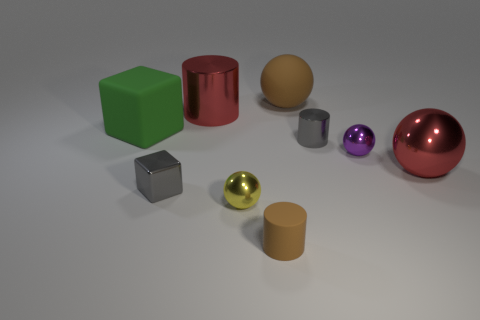There is a brown object that is in front of the small shiny cylinder; what is its shape?
Keep it short and to the point. Cylinder. What is the size of the other cylinder that is made of the same material as the big red cylinder?
Make the answer very short. Small. The matte object that is both in front of the large red cylinder and behind the tiny yellow metallic thing has what shape?
Offer a terse response. Cube. There is a large rubber object that is to the left of the big matte sphere; does it have the same color as the big cylinder?
Make the answer very short. No. There is a small purple shiny thing behind the brown matte cylinder; does it have the same shape as the big shiny object to the left of the gray cylinder?
Offer a terse response. No. What size is the gray metallic object that is to the right of the tiny shiny block?
Your answer should be compact. Small. There is a red thing to the right of the red metal object behind the big red sphere; what size is it?
Provide a short and direct response. Large. Are there more small gray blocks than large balls?
Make the answer very short. No. Is the number of large brown rubber balls on the left side of the green rubber object greater than the number of tiny brown matte cylinders right of the large matte sphere?
Ensure brevity in your answer.  No. What is the size of the metal object that is in front of the big red sphere and to the left of the yellow object?
Keep it short and to the point. Small. 